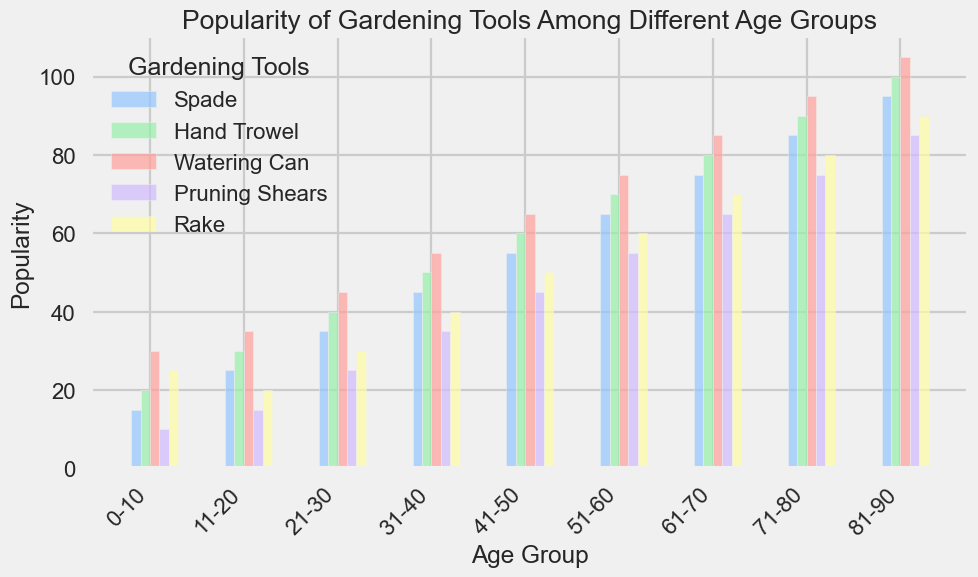What is the most popular gardening tool among the 0-10 age group? By looking at the bar heights for the 0-10 age group, we can see that the Watering Can has the tallest bar, indicating the highest popularity.
Answer: Watering Can Which gardening tool shows the greatest increase in popularity from the 0-10 age group to the 81-90 age group? We need to examine the increase for each tool from the 0-10 age group to the 81-90 age group. Hand Trowel starts at 20 and increases to 100, showing the greatest increase of 80 units.
Answer: Hand Trowel Between the 31-40 and 41-50 age groups, which gardening tool has the largest change in popularity? We compare the changes in popularity for each tool and the Hand Trowel increases from 50 to 60, which is a 10 unit increase, the largest change.
Answer: Hand Trowel Which age group has the least popularity for Pruning Shears? By comparing the bar heights for Pruning Shears across all age groups, the 0-10 age group has the shortest bar corresponding to 10 units.
Answer: 0-10 What is the average popularity of Rake tools across all age groups? The popularity values for the Rake are 25, 20, 30, 40, 50, 60, 70, 80, 90. Summing these values gives 465, and dividing by 9 age groups results in an average popularity of 51.67.
Answer: 51.67 Which tool's popularity increases continuously with every age group? We need to check each tool across all age groups: Hand Trowel (20 to 100), Watering Can (30 to 105), and Pruning Shears (10 to 85) all increase steadily. Spade and Rake do not increase continuously.
Answer: Hand Trowel, Watering Can, Pruning Shears What is the combined popularity of Spade and Hand Trowel in the 51-60 age group? The popularity for Spade is 65 and for Hand Trowel is 70 in the 51-60 age group. Their combined popularity is 65 + 70 = 135.
Answer: 135 